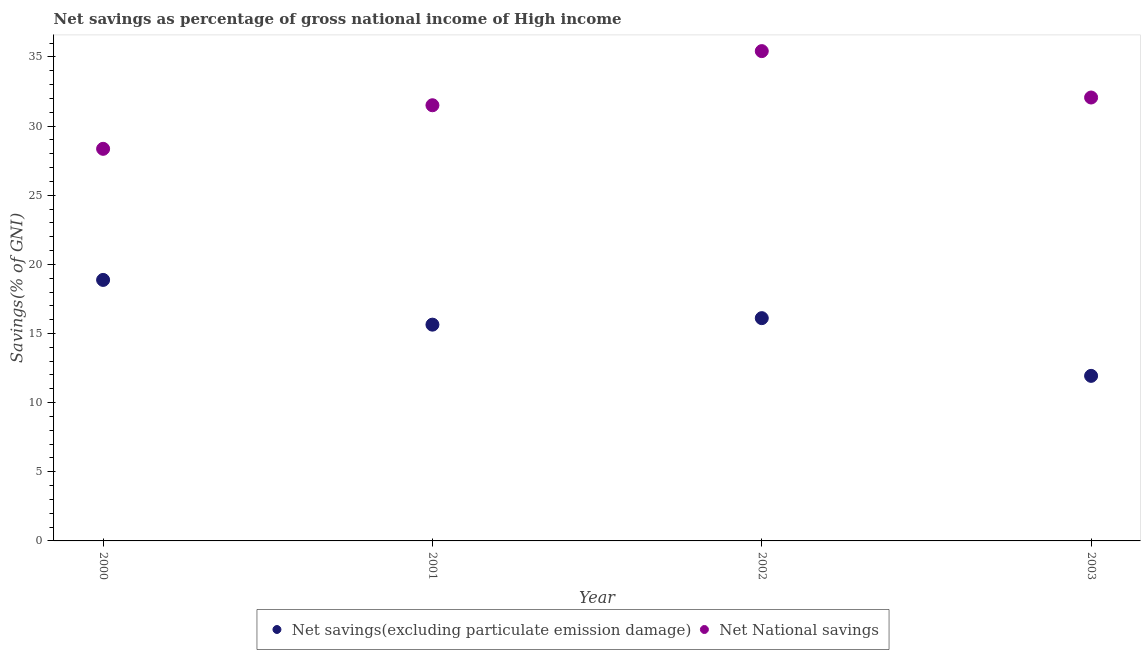How many different coloured dotlines are there?
Your answer should be compact. 2. What is the net national savings in 2000?
Your answer should be compact. 28.36. Across all years, what is the maximum net savings(excluding particulate emission damage)?
Give a very brief answer. 18.87. Across all years, what is the minimum net savings(excluding particulate emission damage)?
Make the answer very short. 11.94. In which year was the net savings(excluding particulate emission damage) minimum?
Make the answer very short. 2003. What is the total net savings(excluding particulate emission damage) in the graph?
Give a very brief answer. 62.56. What is the difference between the net savings(excluding particulate emission damage) in 2002 and that in 2003?
Ensure brevity in your answer.  4.17. What is the difference between the net savings(excluding particulate emission damage) in 2002 and the net national savings in 2000?
Offer a very short reply. -12.24. What is the average net savings(excluding particulate emission damage) per year?
Make the answer very short. 15.64. In the year 2002, what is the difference between the net savings(excluding particulate emission damage) and net national savings?
Offer a terse response. -19.31. In how many years, is the net national savings greater than 20 %?
Offer a very short reply. 4. What is the ratio of the net national savings in 2001 to that in 2003?
Give a very brief answer. 0.98. What is the difference between the highest and the second highest net national savings?
Provide a short and direct response. 3.36. What is the difference between the highest and the lowest net national savings?
Provide a short and direct response. 7.07. Is the sum of the net savings(excluding particulate emission damage) in 2000 and 2001 greater than the maximum net national savings across all years?
Offer a very short reply. No. Is the net national savings strictly less than the net savings(excluding particulate emission damage) over the years?
Keep it short and to the point. No. What is the difference between two consecutive major ticks on the Y-axis?
Your answer should be compact. 5. Does the graph contain any zero values?
Offer a very short reply. No. Where does the legend appear in the graph?
Offer a terse response. Bottom center. What is the title of the graph?
Offer a terse response. Net savings as percentage of gross national income of High income. What is the label or title of the X-axis?
Provide a succinct answer. Year. What is the label or title of the Y-axis?
Keep it short and to the point. Savings(% of GNI). What is the Savings(% of GNI) of Net savings(excluding particulate emission damage) in 2000?
Provide a short and direct response. 18.87. What is the Savings(% of GNI) of Net National savings in 2000?
Ensure brevity in your answer.  28.36. What is the Savings(% of GNI) of Net savings(excluding particulate emission damage) in 2001?
Keep it short and to the point. 15.64. What is the Savings(% of GNI) in Net National savings in 2001?
Offer a terse response. 31.51. What is the Savings(% of GNI) of Net savings(excluding particulate emission damage) in 2002?
Offer a terse response. 16.11. What is the Savings(% of GNI) in Net National savings in 2002?
Your answer should be very brief. 35.42. What is the Savings(% of GNI) of Net savings(excluding particulate emission damage) in 2003?
Your response must be concise. 11.94. What is the Savings(% of GNI) in Net National savings in 2003?
Offer a terse response. 32.07. Across all years, what is the maximum Savings(% of GNI) of Net savings(excluding particulate emission damage)?
Your answer should be compact. 18.87. Across all years, what is the maximum Savings(% of GNI) in Net National savings?
Make the answer very short. 35.42. Across all years, what is the minimum Savings(% of GNI) in Net savings(excluding particulate emission damage)?
Your response must be concise. 11.94. Across all years, what is the minimum Savings(% of GNI) in Net National savings?
Make the answer very short. 28.36. What is the total Savings(% of GNI) of Net savings(excluding particulate emission damage) in the graph?
Ensure brevity in your answer.  62.56. What is the total Savings(% of GNI) in Net National savings in the graph?
Provide a short and direct response. 127.35. What is the difference between the Savings(% of GNI) in Net savings(excluding particulate emission damage) in 2000 and that in 2001?
Ensure brevity in your answer.  3.23. What is the difference between the Savings(% of GNI) of Net National savings in 2000 and that in 2001?
Your response must be concise. -3.15. What is the difference between the Savings(% of GNI) in Net savings(excluding particulate emission damage) in 2000 and that in 2002?
Provide a succinct answer. 2.76. What is the difference between the Savings(% of GNI) in Net National savings in 2000 and that in 2002?
Make the answer very short. -7.07. What is the difference between the Savings(% of GNI) in Net savings(excluding particulate emission damage) in 2000 and that in 2003?
Keep it short and to the point. 6.94. What is the difference between the Savings(% of GNI) of Net National savings in 2000 and that in 2003?
Offer a very short reply. -3.71. What is the difference between the Savings(% of GNI) of Net savings(excluding particulate emission damage) in 2001 and that in 2002?
Offer a terse response. -0.47. What is the difference between the Savings(% of GNI) of Net National savings in 2001 and that in 2002?
Keep it short and to the point. -3.92. What is the difference between the Savings(% of GNI) in Net savings(excluding particulate emission damage) in 2001 and that in 2003?
Offer a terse response. 3.7. What is the difference between the Savings(% of GNI) in Net National savings in 2001 and that in 2003?
Make the answer very short. -0.56. What is the difference between the Savings(% of GNI) in Net savings(excluding particulate emission damage) in 2002 and that in 2003?
Offer a very short reply. 4.17. What is the difference between the Savings(% of GNI) of Net National savings in 2002 and that in 2003?
Offer a very short reply. 3.36. What is the difference between the Savings(% of GNI) of Net savings(excluding particulate emission damage) in 2000 and the Savings(% of GNI) of Net National savings in 2001?
Your answer should be very brief. -12.63. What is the difference between the Savings(% of GNI) of Net savings(excluding particulate emission damage) in 2000 and the Savings(% of GNI) of Net National savings in 2002?
Your answer should be compact. -16.55. What is the difference between the Savings(% of GNI) in Net savings(excluding particulate emission damage) in 2000 and the Savings(% of GNI) in Net National savings in 2003?
Your response must be concise. -13.19. What is the difference between the Savings(% of GNI) of Net savings(excluding particulate emission damage) in 2001 and the Savings(% of GNI) of Net National savings in 2002?
Give a very brief answer. -19.78. What is the difference between the Savings(% of GNI) in Net savings(excluding particulate emission damage) in 2001 and the Savings(% of GNI) in Net National savings in 2003?
Your answer should be compact. -16.43. What is the difference between the Savings(% of GNI) of Net savings(excluding particulate emission damage) in 2002 and the Savings(% of GNI) of Net National savings in 2003?
Your answer should be very brief. -15.96. What is the average Savings(% of GNI) in Net savings(excluding particulate emission damage) per year?
Make the answer very short. 15.64. What is the average Savings(% of GNI) in Net National savings per year?
Keep it short and to the point. 31.84. In the year 2000, what is the difference between the Savings(% of GNI) of Net savings(excluding particulate emission damage) and Savings(% of GNI) of Net National savings?
Ensure brevity in your answer.  -9.48. In the year 2001, what is the difference between the Savings(% of GNI) in Net savings(excluding particulate emission damage) and Savings(% of GNI) in Net National savings?
Provide a succinct answer. -15.87. In the year 2002, what is the difference between the Savings(% of GNI) of Net savings(excluding particulate emission damage) and Savings(% of GNI) of Net National savings?
Your answer should be very brief. -19.31. In the year 2003, what is the difference between the Savings(% of GNI) in Net savings(excluding particulate emission damage) and Savings(% of GNI) in Net National savings?
Your response must be concise. -20.13. What is the ratio of the Savings(% of GNI) in Net savings(excluding particulate emission damage) in 2000 to that in 2001?
Your answer should be very brief. 1.21. What is the ratio of the Savings(% of GNI) of Net National savings in 2000 to that in 2001?
Your answer should be very brief. 0.9. What is the ratio of the Savings(% of GNI) in Net savings(excluding particulate emission damage) in 2000 to that in 2002?
Keep it short and to the point. 1.17. What is the ratio of the Savings(% of GNI) of Net National savings in 2000 to that in 2002?
Offer a very short reply. 0.8. What is the ratio of the Savings(% of GNI) in Net savings(excluding particulate emission damage) in 2000 to that in 2003?
Offer a terse response. 1.58. What is the ratio of the Savings(% of GNI) of Net National savings in 2000 to that in 2003?
Give a very brief answer. 0.88. What is the ratio of the Savings(% of GNI) of Net savings(excluding particulate emission damage) in 2001 to that in 2002?
Your answer should be very brief. 0.97. What is the ratio of the Savings(% of GNI) of Net National savings in 2001 to that in 2002?
Your answer should be very brief. 0.89. What is the ratio of the Savings(% of GNI) in Net savings(excluding particulate emission damage) in 2001 to that in 2003?
Provide a short and direct response. 1.31. What is the ratio of the Savings(% of GNI) in Net National savings in 2001 to that in 2003?
Offer a terse response. 0.98. What is the ratio of the Savings(% of GNI) of Net savings(excluding particulate emission damage) in 2002 to that in 2003?
Your response must be concise. 1.35. What is the ratio of the Savings(% of GNI) in Net National savings in 2002 to that in 2003?
Your answer should be very brief. 1.1. What is the difference between the highest and the second highest Savings(% of GNI) of Net savings(excluding particulate emission damage)?
Offer a very short reply. 2.76. What is the difference between the highest and the second highest Savings(% of GNI) in Net National savings?
Your answer should be very brief. 3.36. What is the difference between the highest and the lowest Savings(% of GNI) in Net savings(excluding particulate emission damage)?
Keep it short and to the point. 6.94. What is the difference between the highest and the lowest Savings(% of GNI) of Net National savings?
Offer a very short reply. 7.07. 